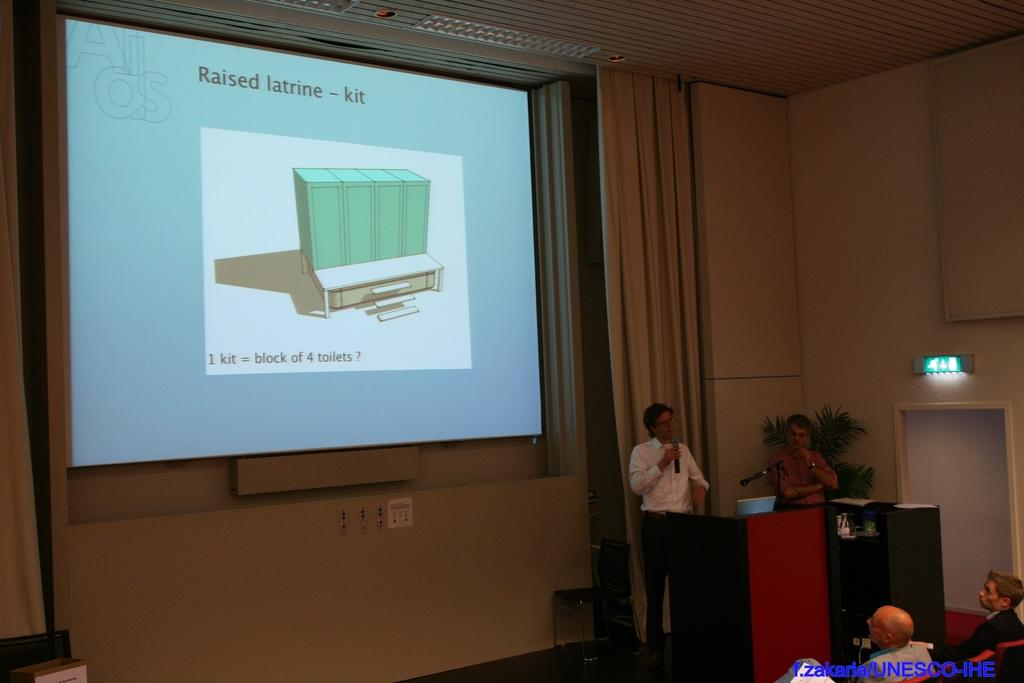<image>
Describe the image concisely. A large projection screen shows the words "Raised latrine-kit" written on it 